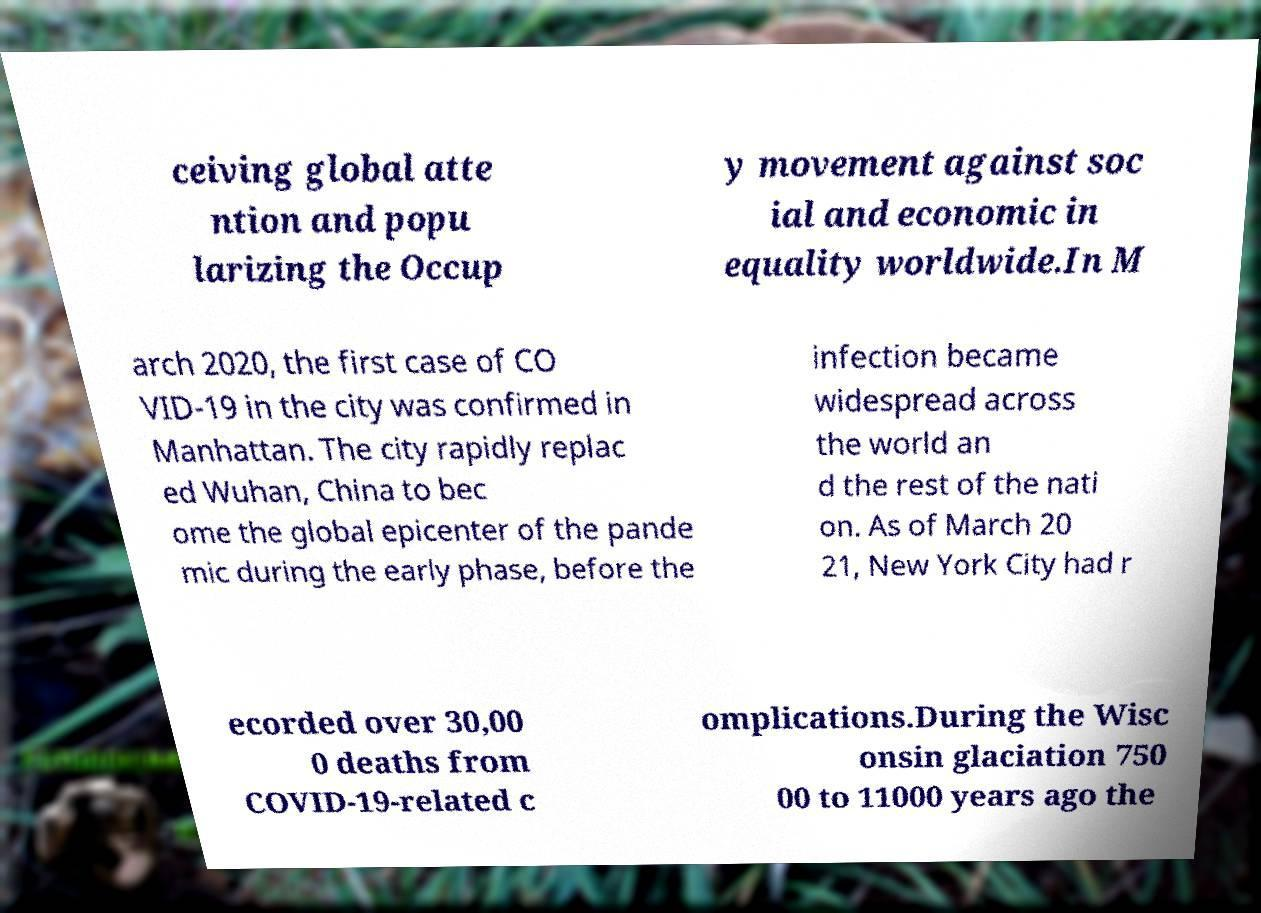I need the written content from this picture converted into text. Can you do that? ceiving global atte ntion and popu larizing the Occup y movement against soc ial and economic in equality worldwide.In M arch 2020, the first case of CO VID-19 in the city was confirmed in Manhattan. The city rapidly replac ed Wuhan, China to bec ome the global epicenter of the pande mic during the early phase, before the infection became widespread across the world an d the rest of the nati on. As of March 20 21, New York City had r ecorded over 30,00 0 deaths from COVID-19-related c omplications.During the Wisc onsin glaciation 750 00 to 11000 years ago the 